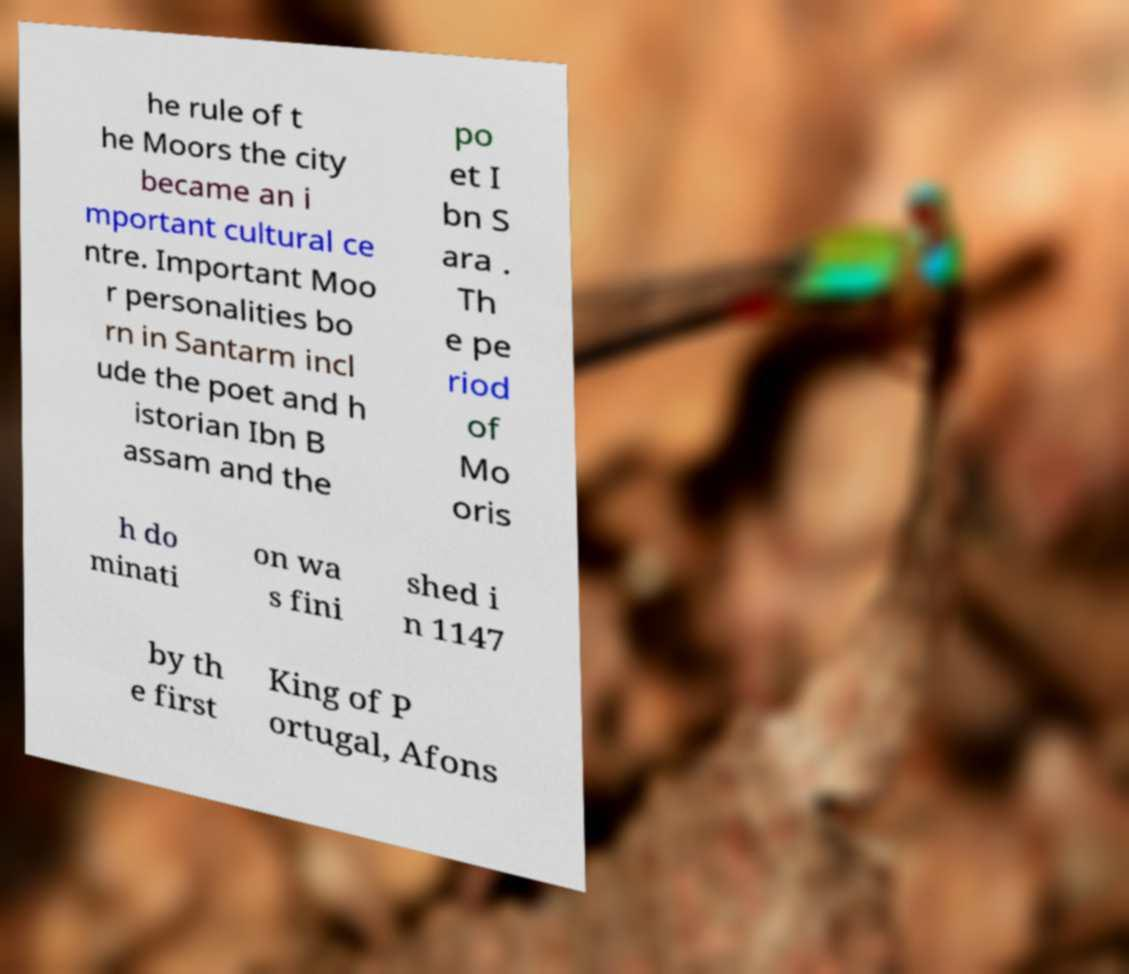Can you read and provide the text displayed in the image?This photo seems to have some interesting text. Can you extract and type it out for me? he rule of t he Moors the city became an i mportant cultural ce ntre. Important Moo r personalities bo rn in Santarm incl ude the poet and h istorian Ibn B assam and the po et I bn S ara . Th e pe riod of Mo oris h do minati on wa s fini shed i n 1147 by th e first King of P ortugal, Afons 